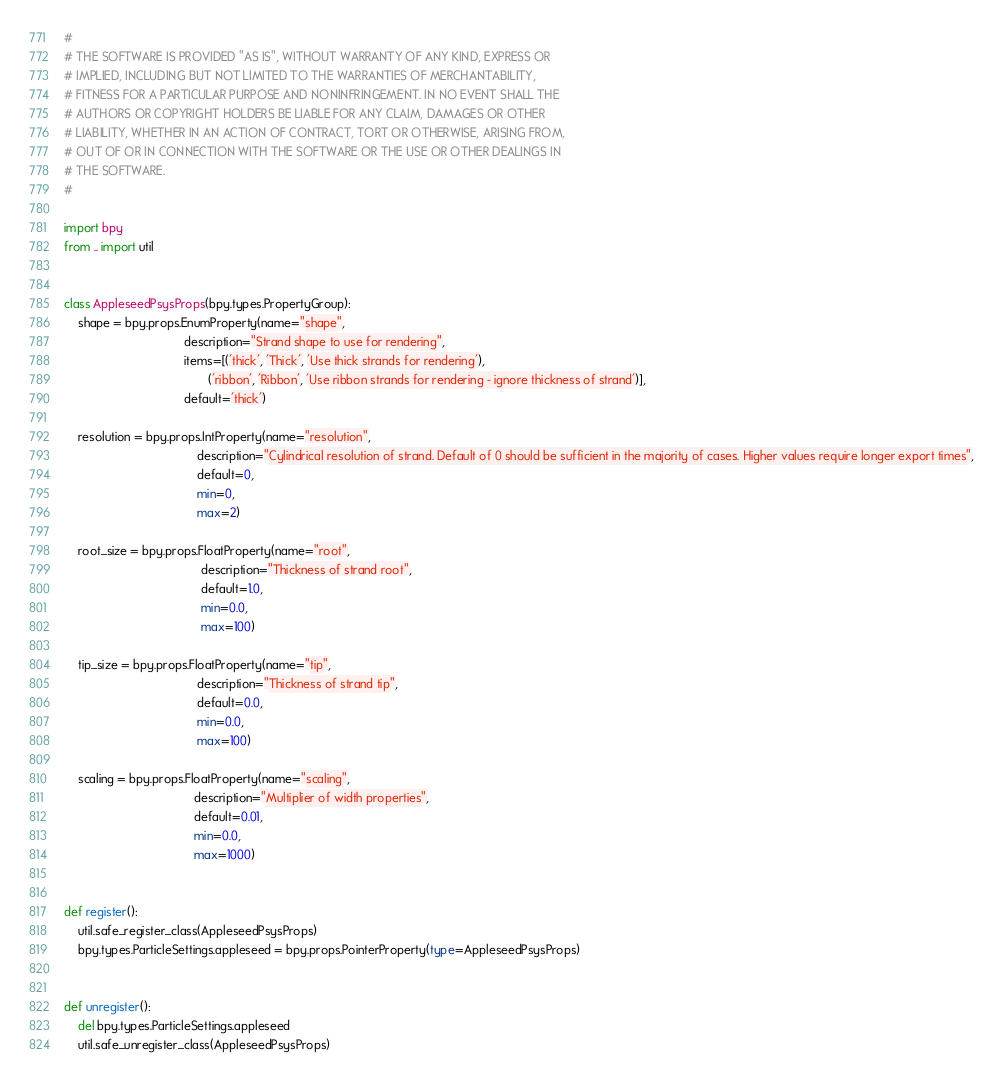Convert code to text. <code><loc_0><loc_0><loc_500><loc_500><_Python_>#
# THE SOFTWARE IS PROVIDED "AS IS", WITHOUT WARRANTY OF ANY KIND, EXPRESS OR
# IMPLIED, INCLUDING BUT NOT LIMITED TO THE WARRANTIES OF MERCHANTABILITY,
# FITNESS FOR A PARTICULAR PURPOSE AND NONINFRINGEMENT. IN NO EVENT SHALL THE
# AUTHORS OR COPYRIGHT HOLDERS BE LIABLE FOR ANY CLAIM, DAMAGES OR OTHER
# LIABILITY, WHETHER IN AN ACTION OF CONTRACT, TORT OR OTHERWISE, ARISING FROM,
# OUT OF OR IN CONNECTION WITH THE SOFTWARE OR THE USE OR OTHER DEALINGS IN
# THE SOFTWARE.
#

import bpy
from .. import util


class AppleseedPsysProps(bpy.types.PropertyGroup):
    shape = bpy.props.EnumProperty(name="shape",
                                   description="Strand shape to use for rendering",
                                   items=[('thick', 'Thick', 'Use thick strands for rendering'),
                                          ('ribbon', 'Ribbon', 'Use ribbon strands for rendering - ignore thickness of strand')],
                                   default='thick')

    resolution = bpy.props.IntProperty(name="resolution",
                                       description="Cylindrical resolution of strand. Default of 0 should be sufficient in the majority of cases. Higher values require longer export times",
                                       default=0,
                                       min=0,
                                       max=2)

    root_size = bpy.props.FloatProperty(name="root",
                                        description="Thickness of strand root",
                                        default=1.0,
                                        min=0.0,
                                        max=100)

    tip_size = bpy.props.FloatProperty(name="tip",
                                       description="Thickness of strand tip",
                                       default=0.0,
                                       min=0.0,
                                       max=100)

    scaling = bpy.props.FloatProperty(name="scaling",
                                      description="Multiplier of width properties",
                                      default=0.01,
                                      min=0.0,
                                      max=1000)


def register():
    util.safe_register_class(AppleseedPsysProps)
    bpy.types.ParticleSettings.appleseed = bpy.props.PointerProperty(type=AppleseedPsysProps)


def unregister():
    del bpy.types.ParticleSettings.appleseed
    util.safe_unregister_class(AppleseedPsysProps)
</code> 